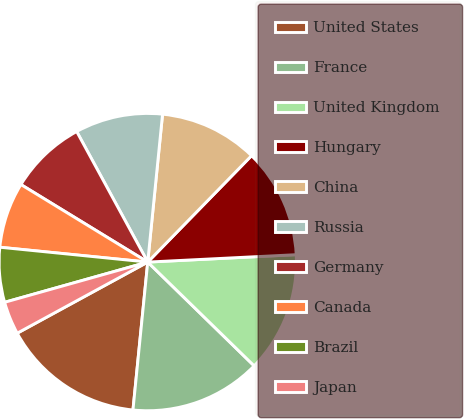<chart> <loc_0><loc_0><loc_500><loc_500><pie_chart><fcel>United States<fcel>France<fcel>United Kingdom<fcel>Hungary<fcel>China<fcel>Russia<fcel>Germany<fcel>Canada<fcel>Brazil<fcel>Japan<nl><fcel>15.47%<fcel>14.28%<fcel>13.09%<fcel>11.9%<fcel>10.71%<fcel>9.52%<fcel>8.33%<fcel>7.14%<fcel>5.95%<fcel>3.58%<nl></chart> 